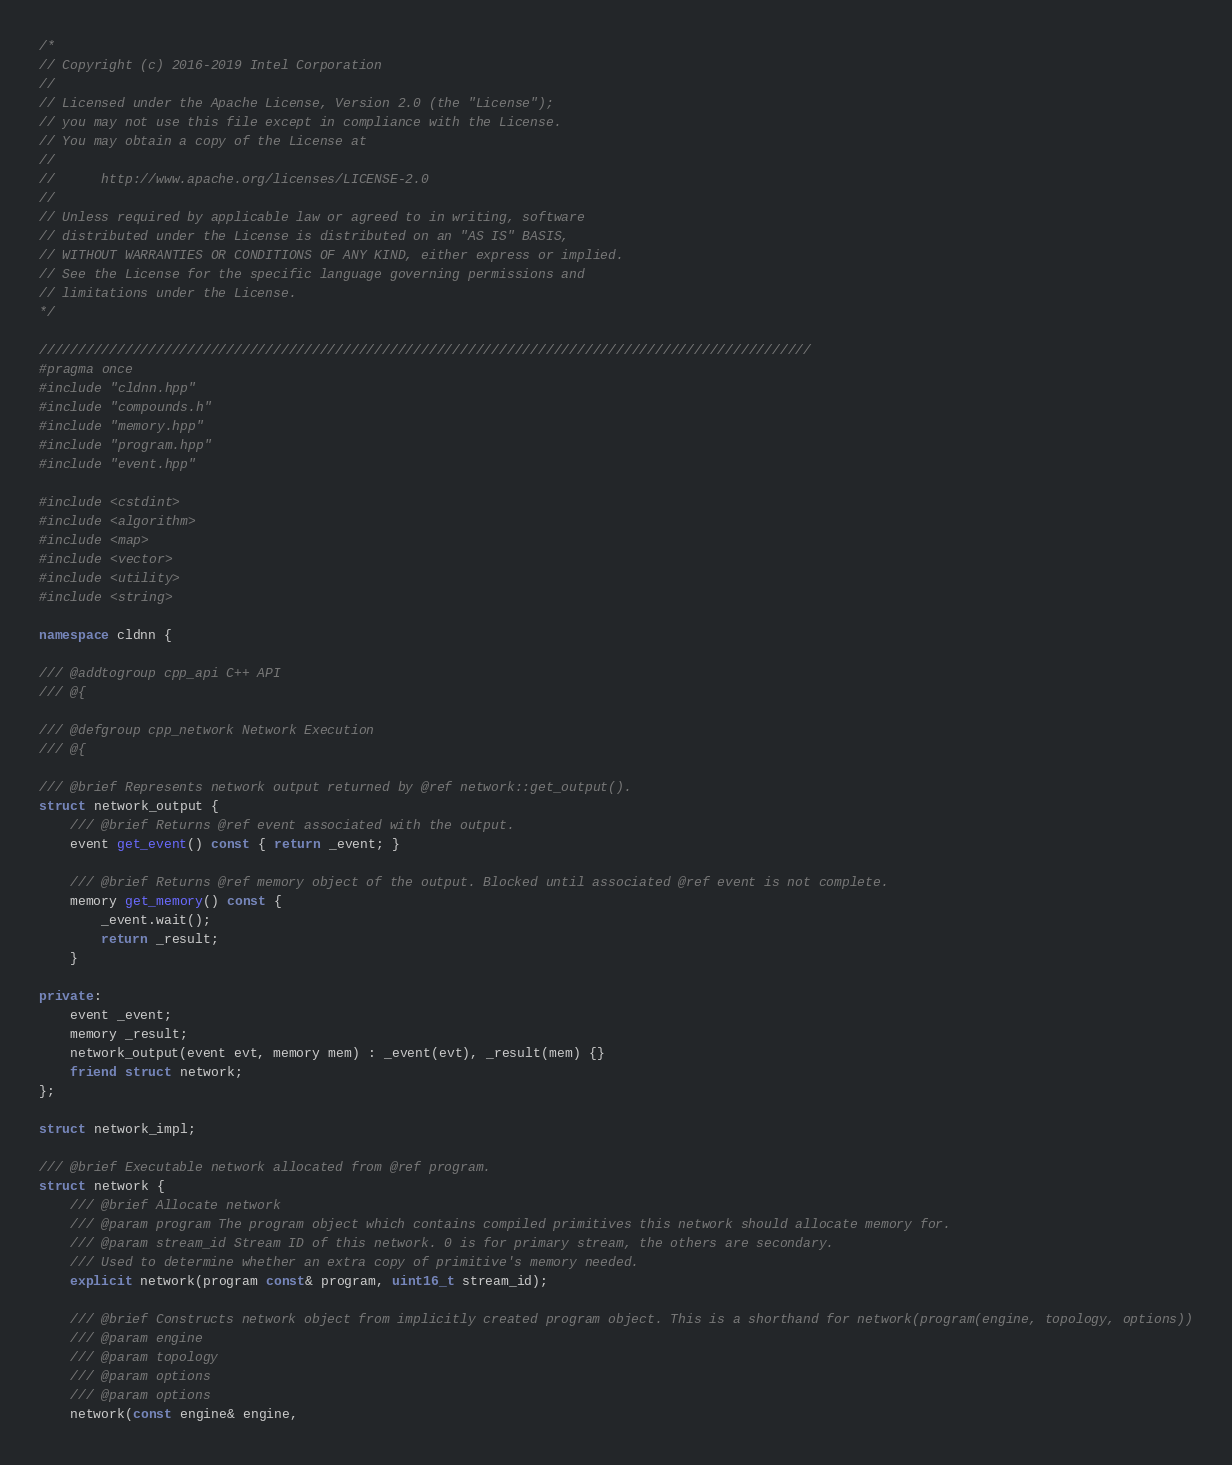Convert code to text. <code><loc_0><loc_0><loc_500><loc_500><_C++_>/*
// Copyright (c) 2016-2019 Intel Corporation
//
// Licensed under the Apache License, Version 2.0 (the "License");
// you may not use this file except in compliance with the License.
// You may obtain a copy of the License at
//
//      http://www.apache.org/licenses/LICENSE-2.0
//
// Unless required by applicable law or agreed to in writing, software
// distributed under the License is distributed on an "AS IS" BASIS,
// WITHOUT WARRANTIES OR CONDITIONS OF ANY KIND, either express or implied.
// See the License for the specific language governing permissions and
// limitations under the License.
*/

///////////////////////////////////////////////////////////////////////////////////////////////////
#pragma once
#include "cldnn.hpp"
#include "compounds.h"
#include "memory.hpp"
#include "program.hpp"
#include "event.hpp"

#include <cstdint>
#include <algorithm>
#include <map>
#include <vector>
#include <utility>
#include <string>

namespace cldnn {

/// @addtogroup cpp_api C++ API
/// @{

/// @defgroup cpp_network Network Execution
/// @{

/// @brief Represents network output returned by @ref network::get_output().
struct network_output {
    /// @brief Returns @ref event associated with the output.
    event get_event() const { return _event; }

    /// @brief Returns @ref memory object of the output. Blocked until associated @ref event is not complete.
    memory get_memory() const {
        _event.wait();
        return _result;
    }

private:
    event _event;
    memory _result;
    network_output(event evt, memory mem) : _event(evt), _result(mem) {}
    friend struct network;
};

struct network_impl;

/// @brief Executable network allocated from @ref program.
struct network {
    /// @brief Allocate network
    /// @param program The program object which contains compiled primitives this network should allocate memory for.
    /// @param stream_id Stream ID of this network. 0 is for primary stream, the others are secondary.
    /// Used to determine whether an extra copy of primitive's memory needed.
    explicit network(program const& program, uint16_t stream_id);

    /// @brief Constructs network object from implicitly created program object. This is a shorthand for network(program(engine, topology, options))
    /// @param engine
    /// @param topology
    /// @param options
    /// @param options
    network(const engine& engine,</code> 